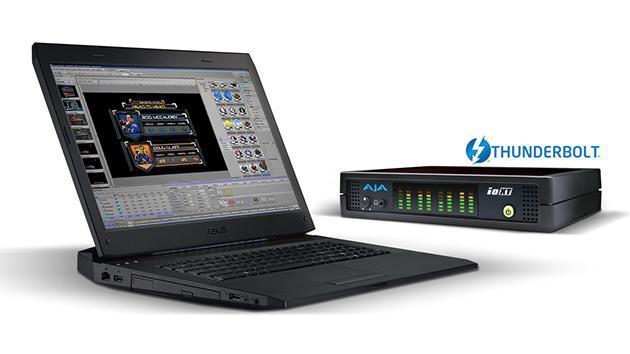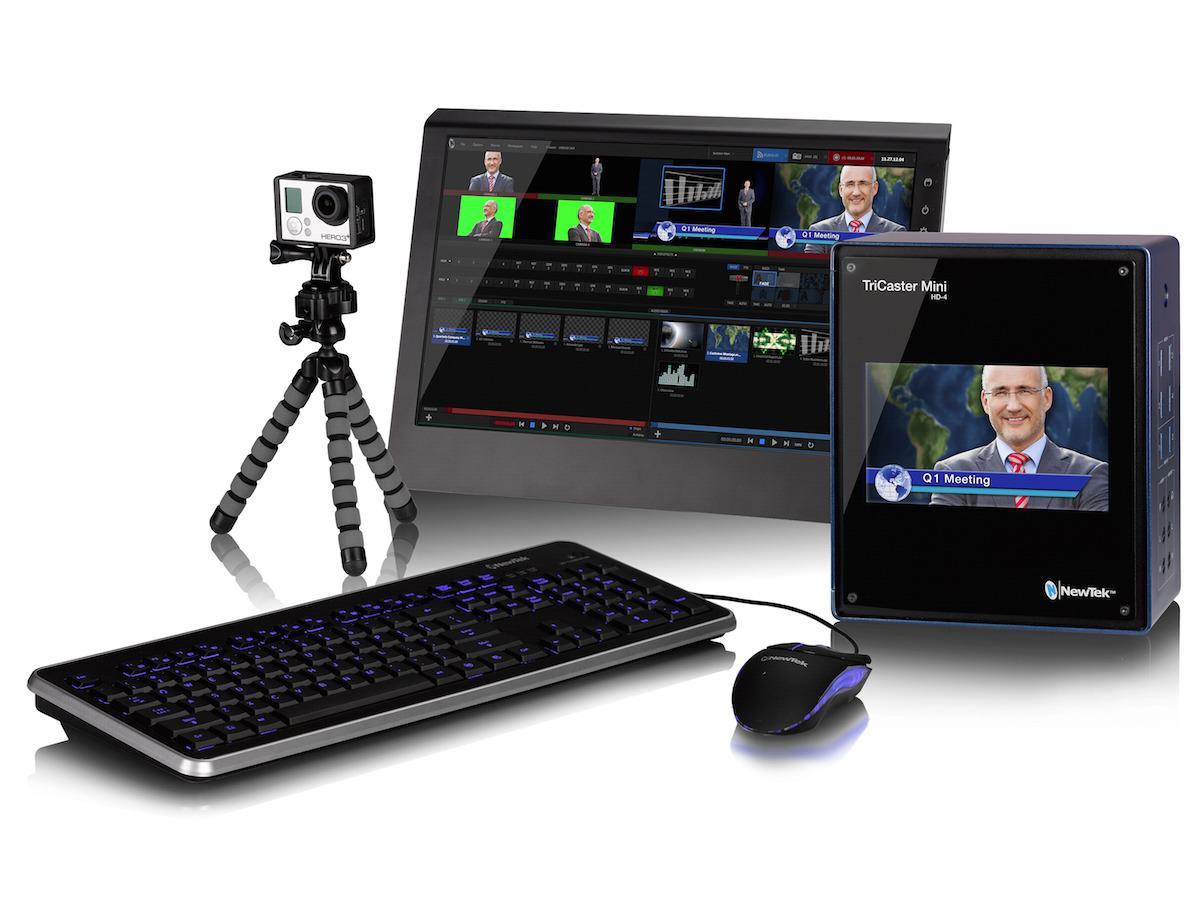The first image is the image on the left, the second image is the image on the right. For the images displayed, is the sentence "One of the images contains a VCR." factually correct? Answer yes or no. No. 